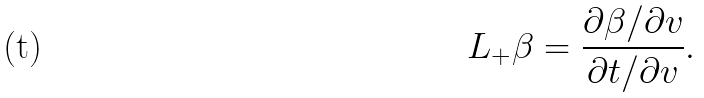<formula> <loc_0><loc_0><loc_500><loc_500>L _ { + } \beta = \frac { \partial \beta / \partial v } { \partial t / \partial v } .</formula> 